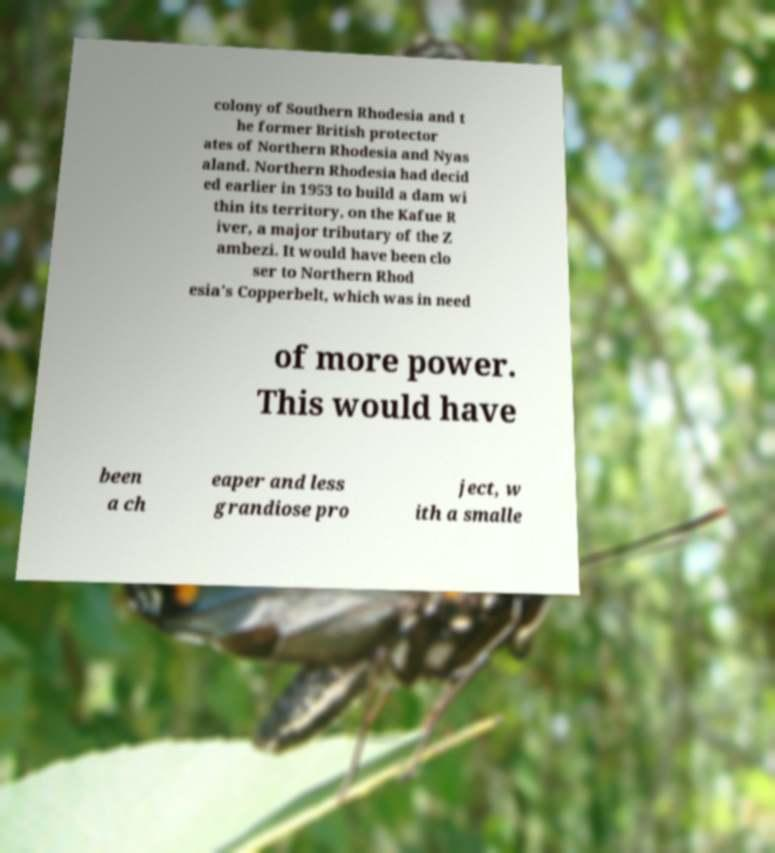What messages or text are displayed in this image? I need them in a readable, typed format. colony of Southern Rhodesia and t he former British protector ates of Northern Rhodesia and Nyas aland. Northern Rhodesia had decid ed earlier in 1953 to build a dam wi thin its territory, on the Kafue R iver, a major tributary of the Z ambezi. It would have been clo ser to Northern Rhod esia's Copperbelt, which was in need of more power. This would have been a ch eaper and less grandiose pro ject, w ith a smalle 